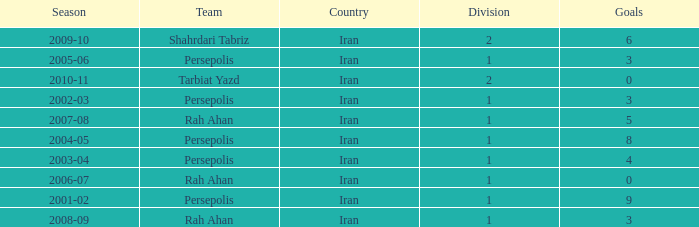What is the average Goals, when Team is "Rah Ahan", and when Division is less than 1? None. 